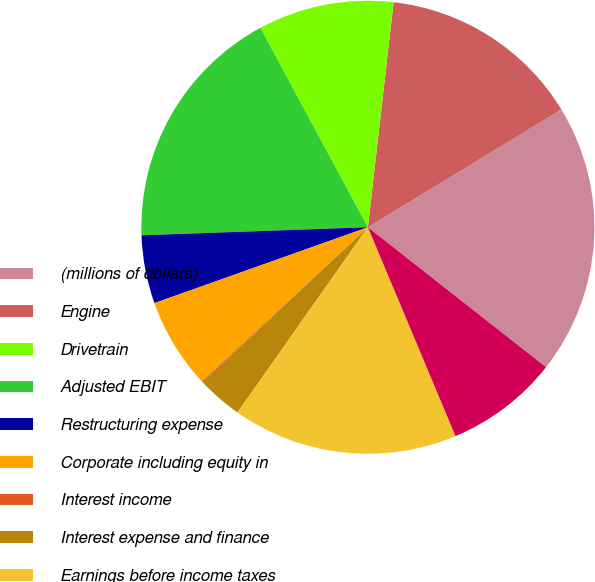Convert chart to OTSL. <chart><loc_0><loc_0><loc_500><loc_500><pie_chart><fcel>(millions of dollars)<fcel>Engine<fcel>Drivetrain<fcel>Adjusted EBIT<fcel>Restructuring expense<fcel>Corporate including equity in<fcel>Interest income<fcel>Interest expense and finance<fcel>Earnings before income taxes<fcel>Provision for income taxes<nl><fcel>19.3%<fcel>14.49%<fcel>9.68%<fcel>17.7%<fcel>4.87%<fcel>6.47%<fcel>0.06%<fcel>3.27%<fcel>16.09%<fcel>8.08%<nl></chart> 